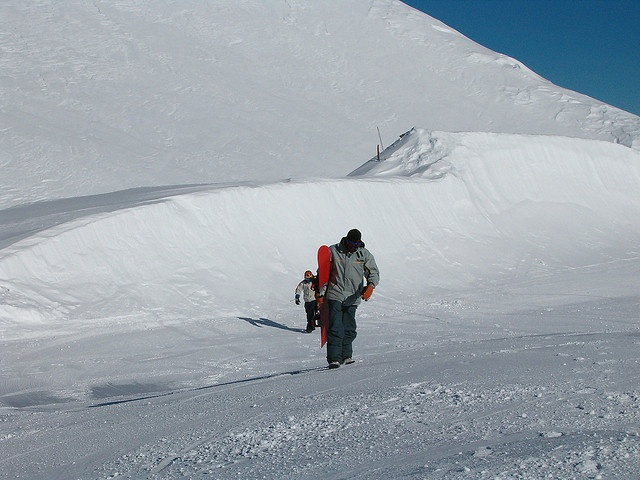Describe the objects in this image and their specific colors. I can see people in darkgray, black, and gray tones, snowboard in darkgray, brown, black, and maroon tones, and people in darkgray, black, gray, and maroon tones in this image. 